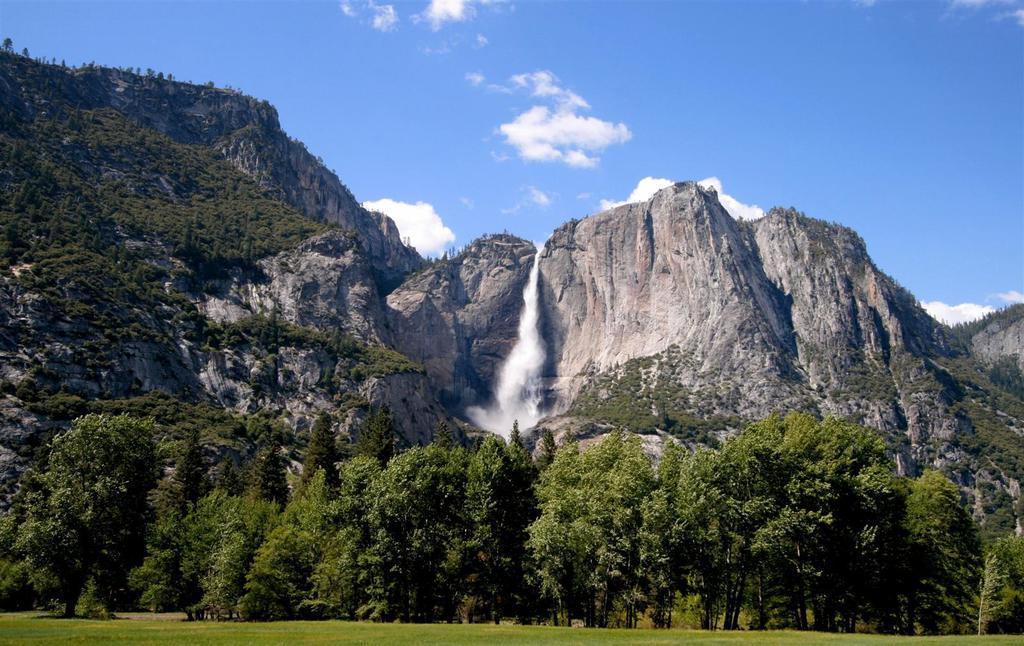How would you summarize this image in a sentence or two? In the image there are many plants and trees behind a grass surface and in the background there is a huge mountain and there is a water fall in between the mountain. 